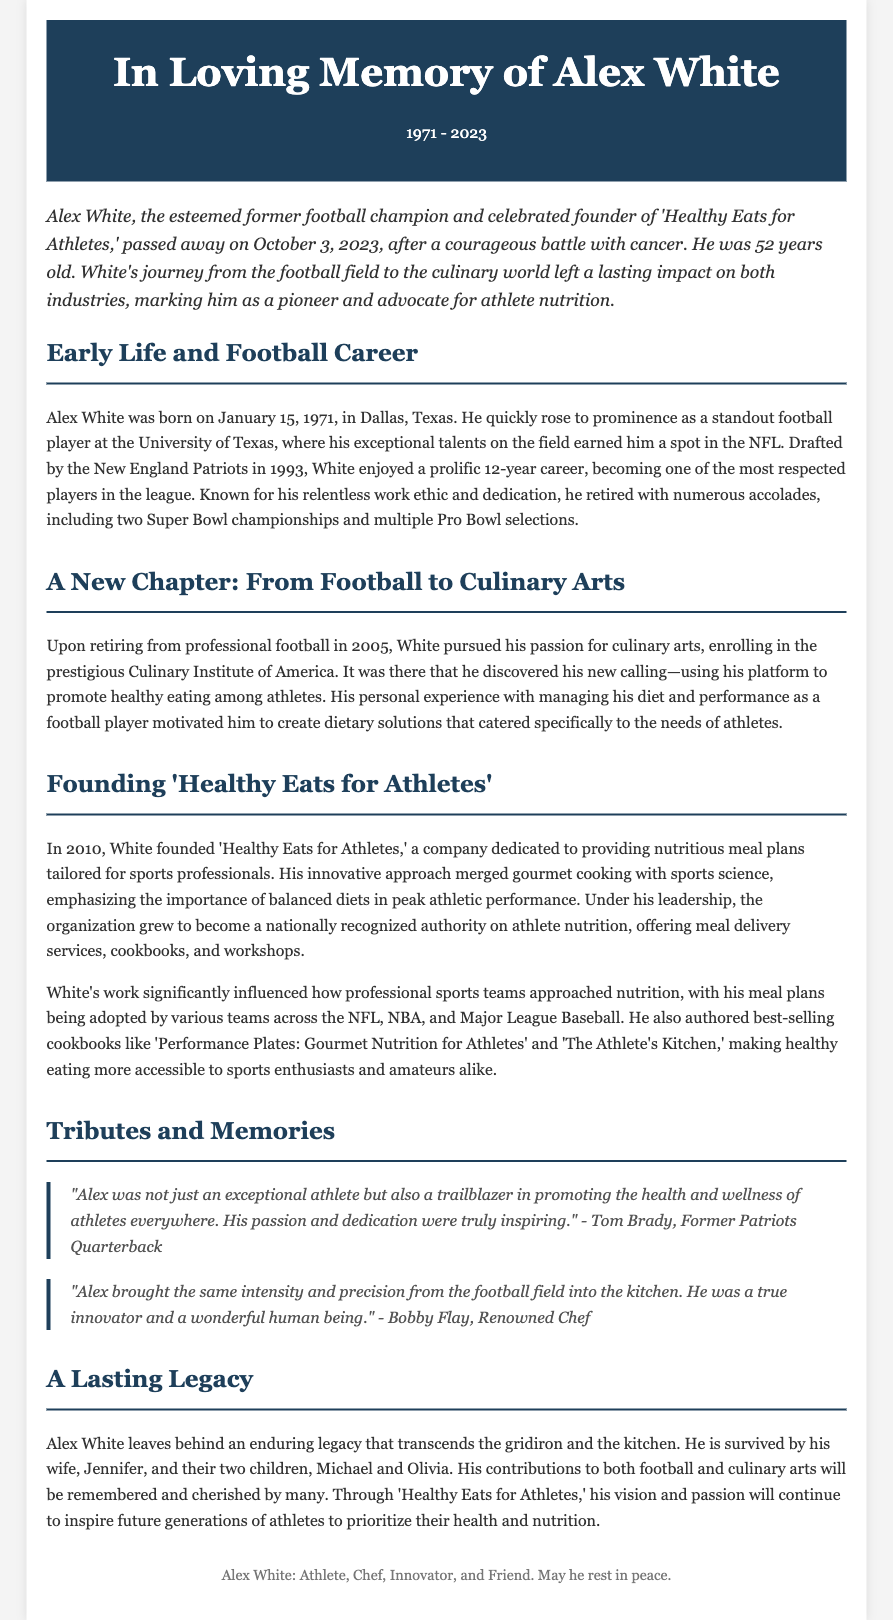what was Alex White's birth date? The document states Alex White was born on January 15, 1971.
Answer: January 15, 1971 how old was Alex White when he passed away? The document mentions he was 52 years old when he died on October 3, 2023.
Answer: 52 years old what was the name of the company Alex White founded? The document refers to the company he founded as 'Healthy Eats for Athletes.'
Answer: Healthy Eats for Athletes how many Super Bowl championships did Alex White win? The document states he won two Super Bowl championships during his career.
Answer: two who praised Alex White's contributions as a trailblazer? The document includes a quote from Tom Brady praising him.
Answer: Tom Brady what year did Alex White retire from professional football? The document indicates he retired in 2005.
Answer: 2005 which culinary institute did Alex White attend? According to the document, he enrolled in the Culinary Institute of America.
Answer: Culinary Institute of America what kind of books did Alex White author? The document mentions he authored best-selling cookbooks focused on nutrition for athletes.
Answer: cookbooks what was Alex White's impact on professional sports teams regarding nutrition? The document states his meal plans were adopted by various teams across different sports leagues.
Answer: adopted by various teams 